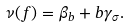Convert formula to latex. <formula><loc_0><loc_0><loc_500><loc_500>\nu ( f ) = \beta _ { b } + b \gamma _ { \sigma } .</formula> 